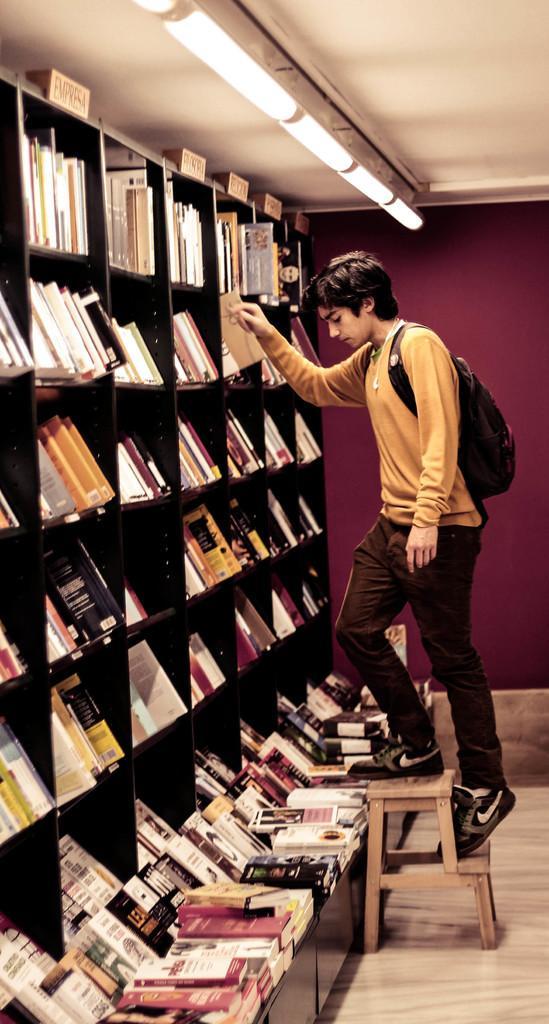Describe this image in one or two sentences. In this picture I can see a man on the stool and I see that he is wearing a bag. On the left side of this picture I see the racks on which there are number of books. On the top of this picture I see the lights. In the background I see the wall. 